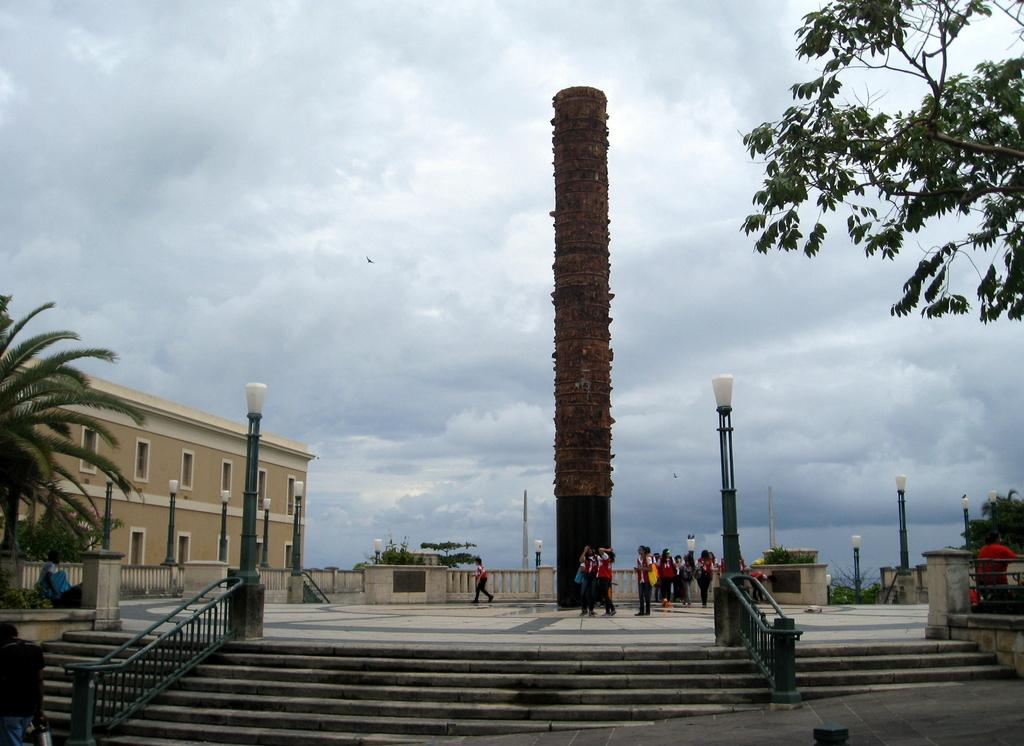What type of structure can be seen in the image? There is a building in the image. What natural elements are present in the image? There are trees in the image. What type of lighting is visible in the image? Pole lights are visible in the image. Are there any architectural features that can be observed? Yes, there are steps and a pillar present in the image. What type of barrier is observable in the image? A fence is observable in the image. What other objects can be seen in the image? There are other objects in the image, but their specific details are not mentioned in the facts. What can be seen in the background of the image? The sky is visible in the background of the image. How does the smoke affect the attention of the people in the image? There is no mention of smoke or people in the image, so this question cannot be answered. 